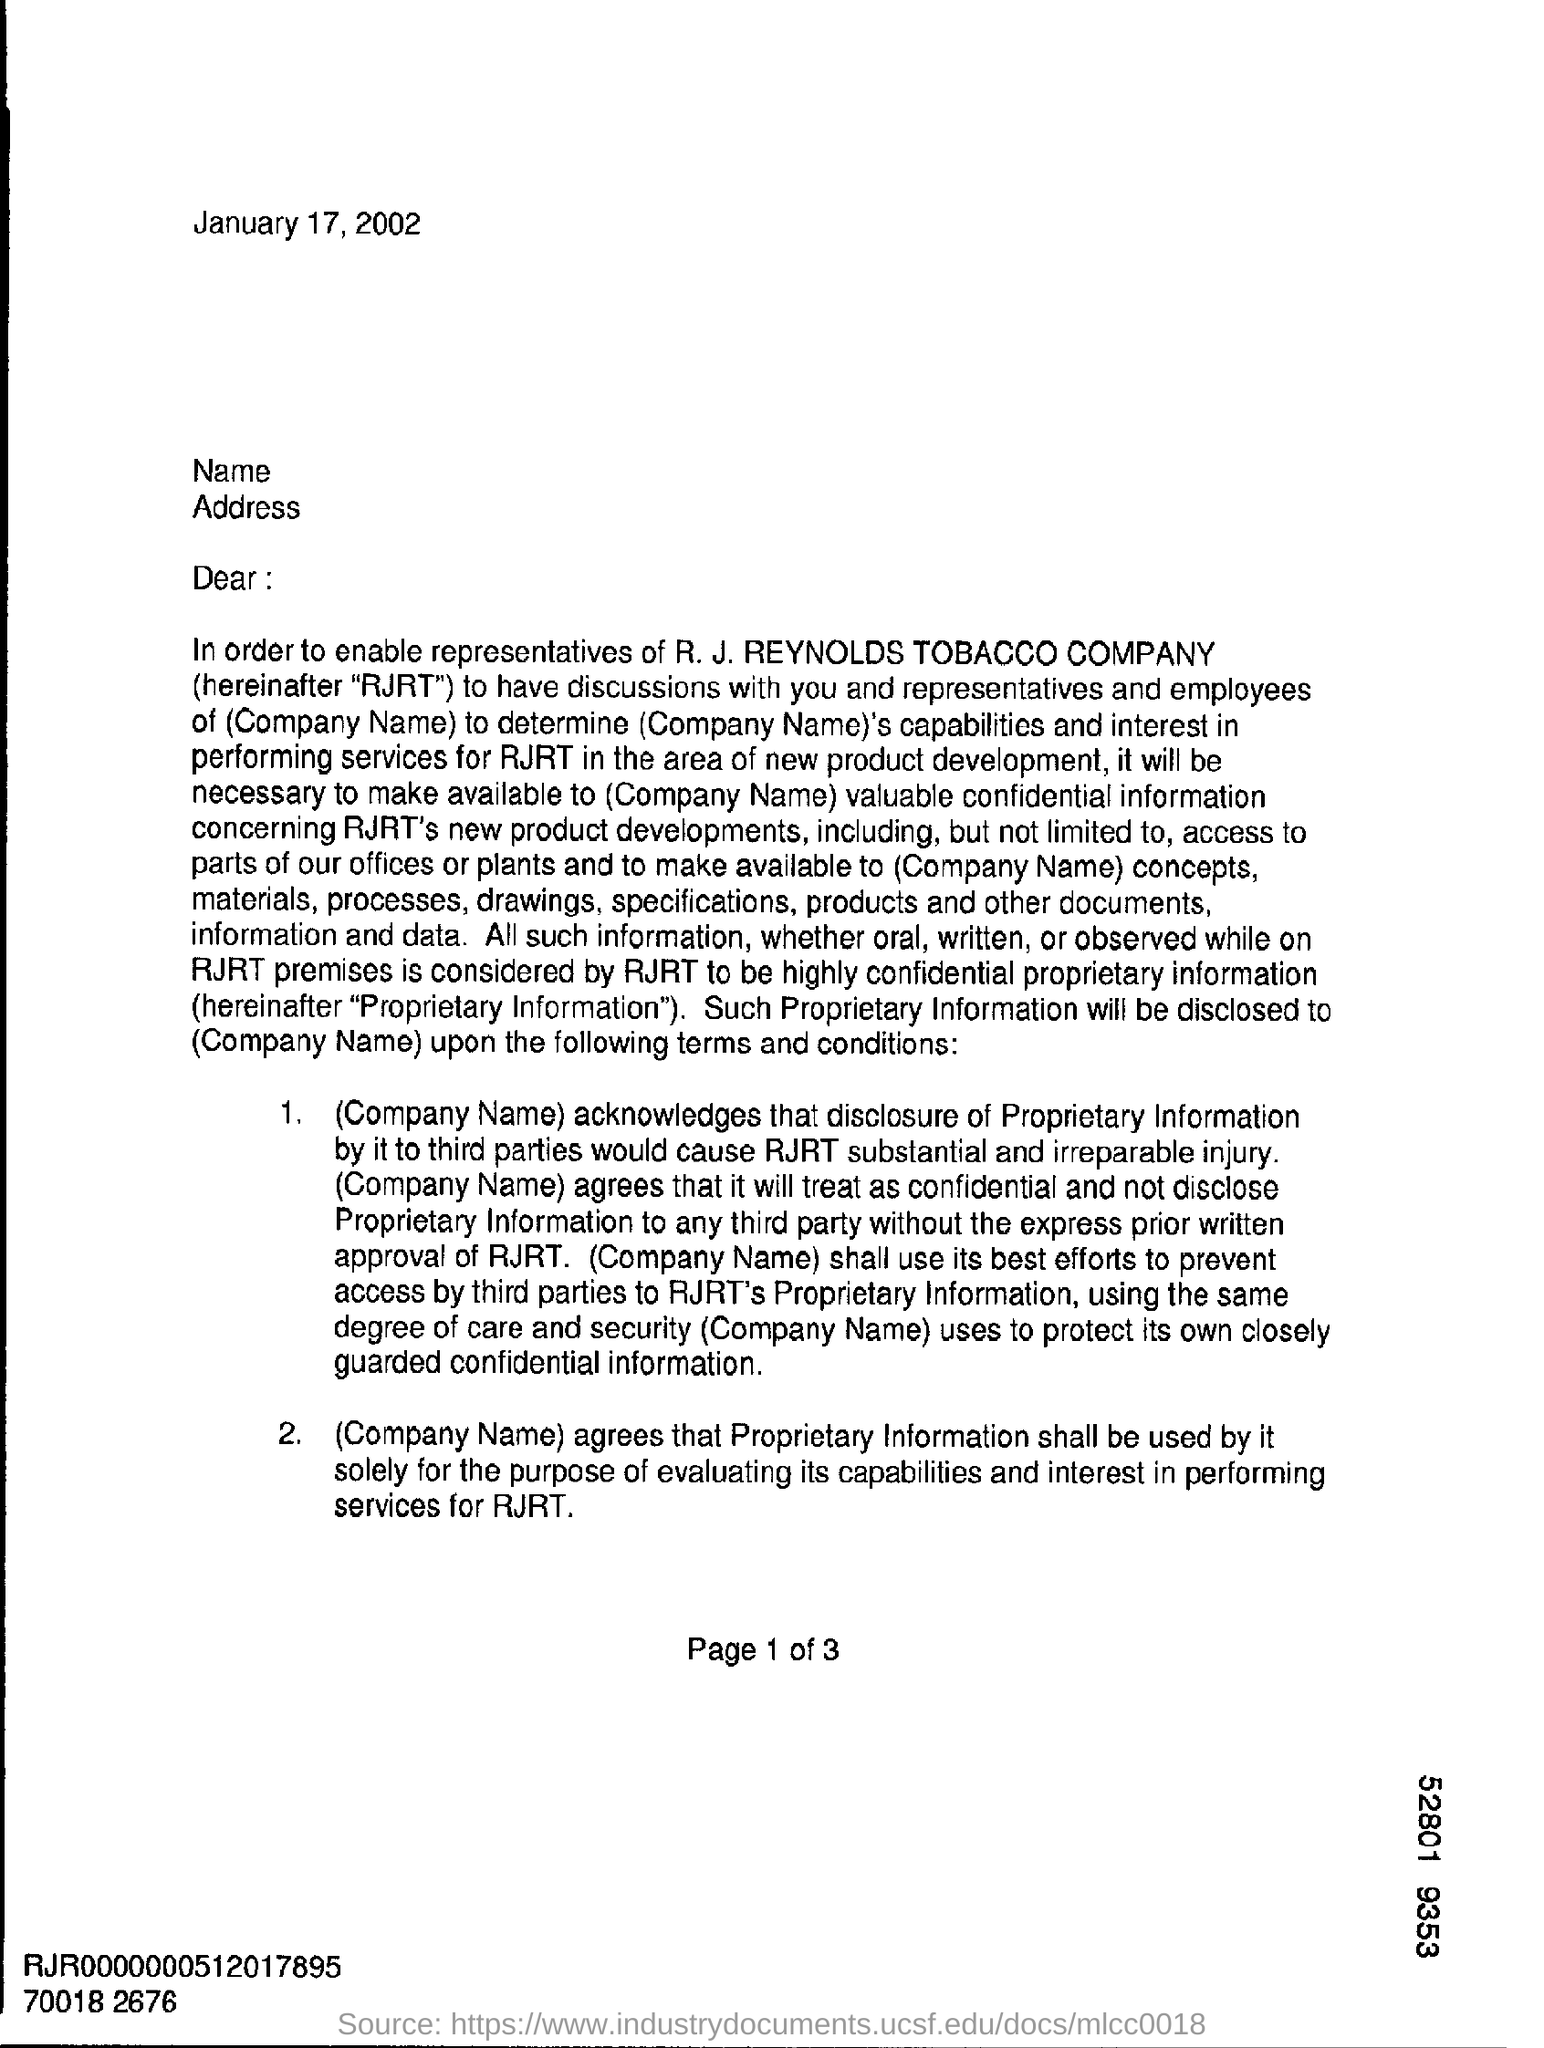Indicate a few pertinent items in this graphic. The date on the document is January 17, 2002. 